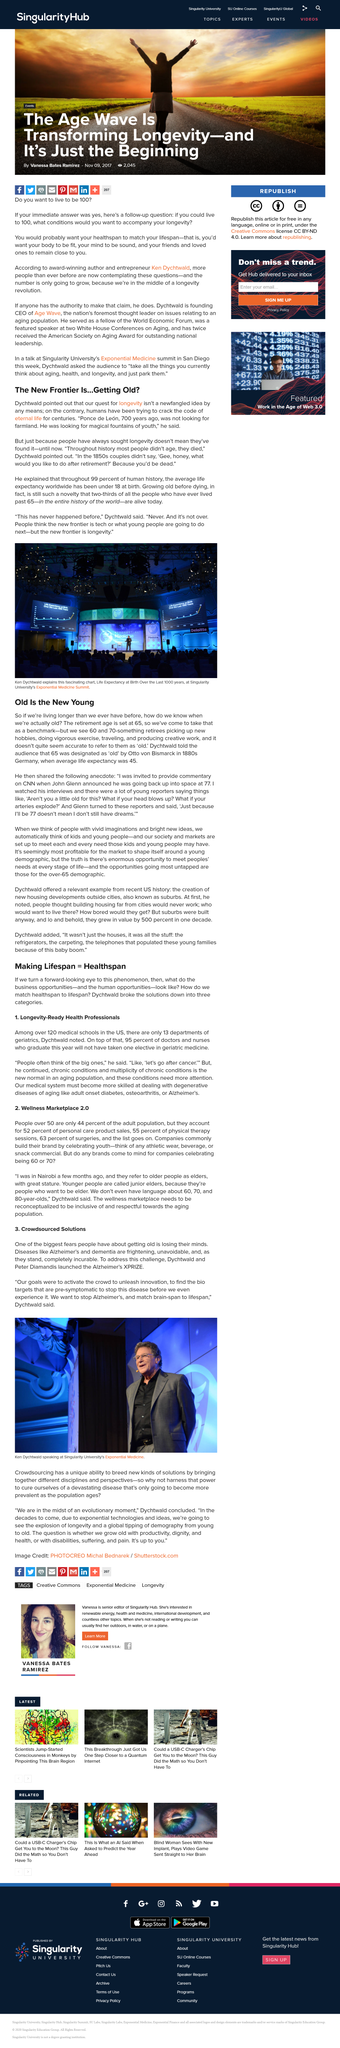Outline some significant characteristics in this image. John Glenn was 77 years old when he went back into space. There are over 120 medical schools in the United States. There are currently 13 departments of geriatrics in medical schools across the United States. For centuries, humans have been attempting to unlock the secret of eternal life. We are proud to announce the launch of the Alzheimer's XPRIZE, initiated by Dychtwald and Diamandis, which aims to incentivize the development of a diagnostic test or treatments for Alzheimer's disease. 